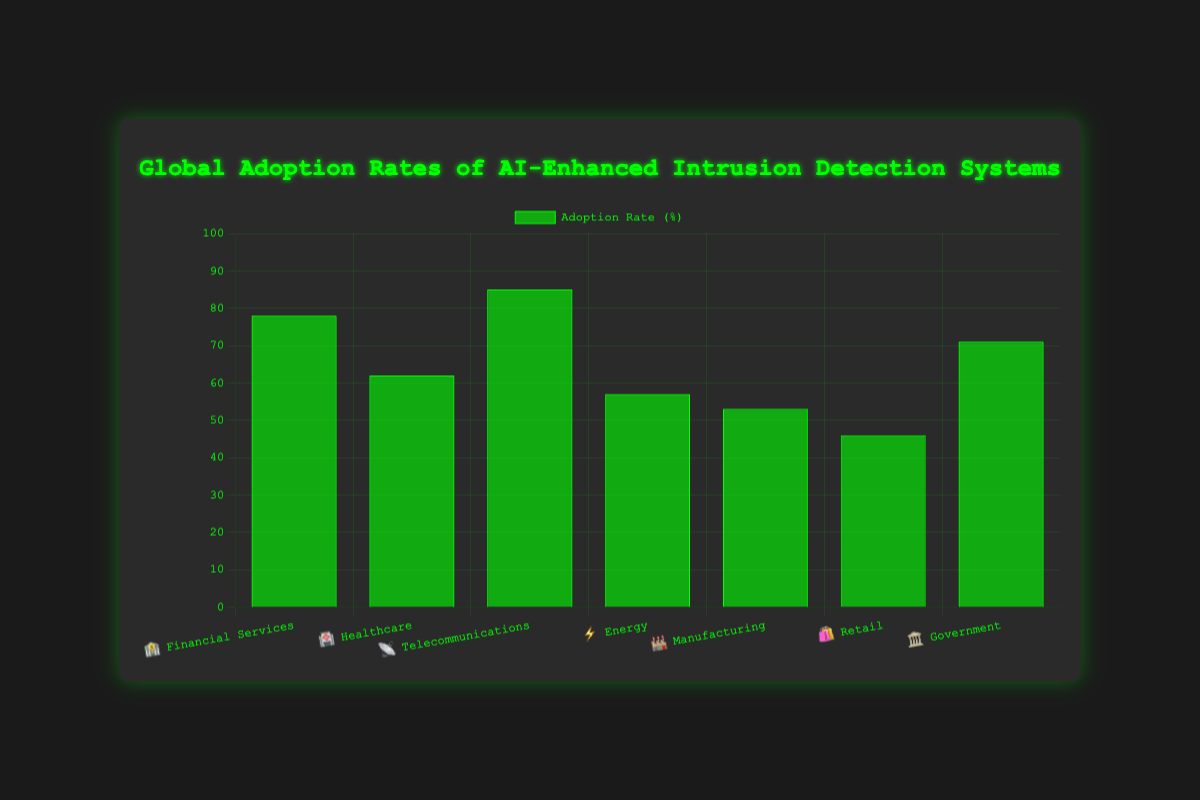What's the adoption rate of AI-enhanced intrusion detection systems in Healthcare? The figure shows the adoption rates for different industries, and for Healthcare, it is visually marked.
Answer: 62% What is the title of the figure? The title is displayed at the top of the figure, summarizing the main information it represents.
Answer: Global Adoption Rates of AI-Enhanced Intrusion Detection Systems Which industry has the highest adoption rate? By comparing the heights of the bars, the industry with the largest bar is identified. Telecommunications has the highest bar.
Answer: Telecommunications What is the average adoption rate across all industries? Add all the adoption rates together (78 + 62 + 85 + 57 + 53 + 46 + 71) and then divide by the number of industries (7). (452 / 7 ≈ 64.57)
Answer: ~64.57% How much higher is the adoption rate in Government than in Retail? Subtract the adoption rate of Retail from that of Government. (71 - 46)
Answer: 25% Which industry has the lowest adoption rate? By comparing the heights of the bars, the industry with the smallest bar is identified. Retail has the lowest bar.
Answer: Retail What's the adoption rate difference between Energy and Financial Services? Subtract the adoption rate of Energy from that of Financial Services. (78 - 57)
Answer: 21% Rank the industries from highest to lowest adoption rate. Sort the industries based on the height of their bars in descending order: Telecommunications, Financial Services, Government, Healthcare, Energy, Manufacturing, Retail.
Answer: Telecommunications, Financial Services, Government, Healthcare, Energy, Manufacturing, Retail What's the total adoption rate if all industries are combined? Sum up all the adoption rates. (78 + 62 + 85 + 57 + 53 + 46 + 71 = 452)
Answer: 452 What proportion of industries have an adoption rate above 60%? Count industries with rates above 60% and divide by total industries. (5 out of 7: Financial Services, Healthcare, Telecommunications, Government, and Energy)
Answer: 5/7 